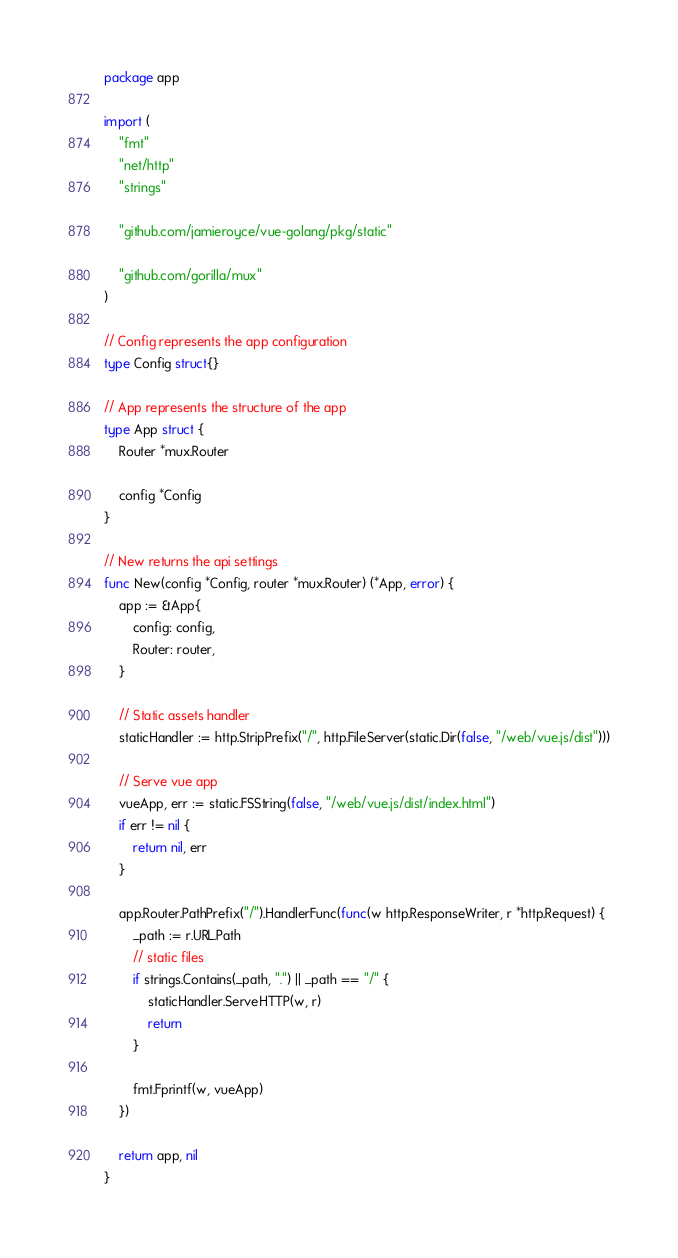Convert code to text. <code><loc_0><loc_0><loc_500><loc_500><_Go_>package app

import (
	"fmt"
	"net/http"
	"strings"

	"github.com/jamieroyce/vue-golang/pkg/static"

	"github.com/gorilla/mux"
)

// Config represents the app configuration
type Config struct{}

// App represents the structure of the app
type App struct {
	Router *mux.Router

	config *Config
}

// New returns the api settings
func New(config *Config, router *mux.Router) (*App, error) {
	app := &App{
		config: config,
		Router: router,
	}

	// Static assets handler
	staticHandler := http.StripPrefix("/", http.FileServer(static.Dir(false, "/web/vue.js/dist")))

	// Serve vue app
	vueApp, err := static.FSString(false, "/web/vue.js/dist/index.html")
	if err != nil {
		return nil, err
	}

	app.Router.PathPrefix("/").HandlerFunc(func(w http.ResponseWriter, r *http.Request) {
		_path := r.URL.Path
		// static files
		if strings.Contains(_path, ".") || _path == "/" {
			staticHandler.ServeHTTP(w, r)
			return
		}

		fmt.Fprintf(w, vueApp)
	})

	return app, nil
}
</code> 